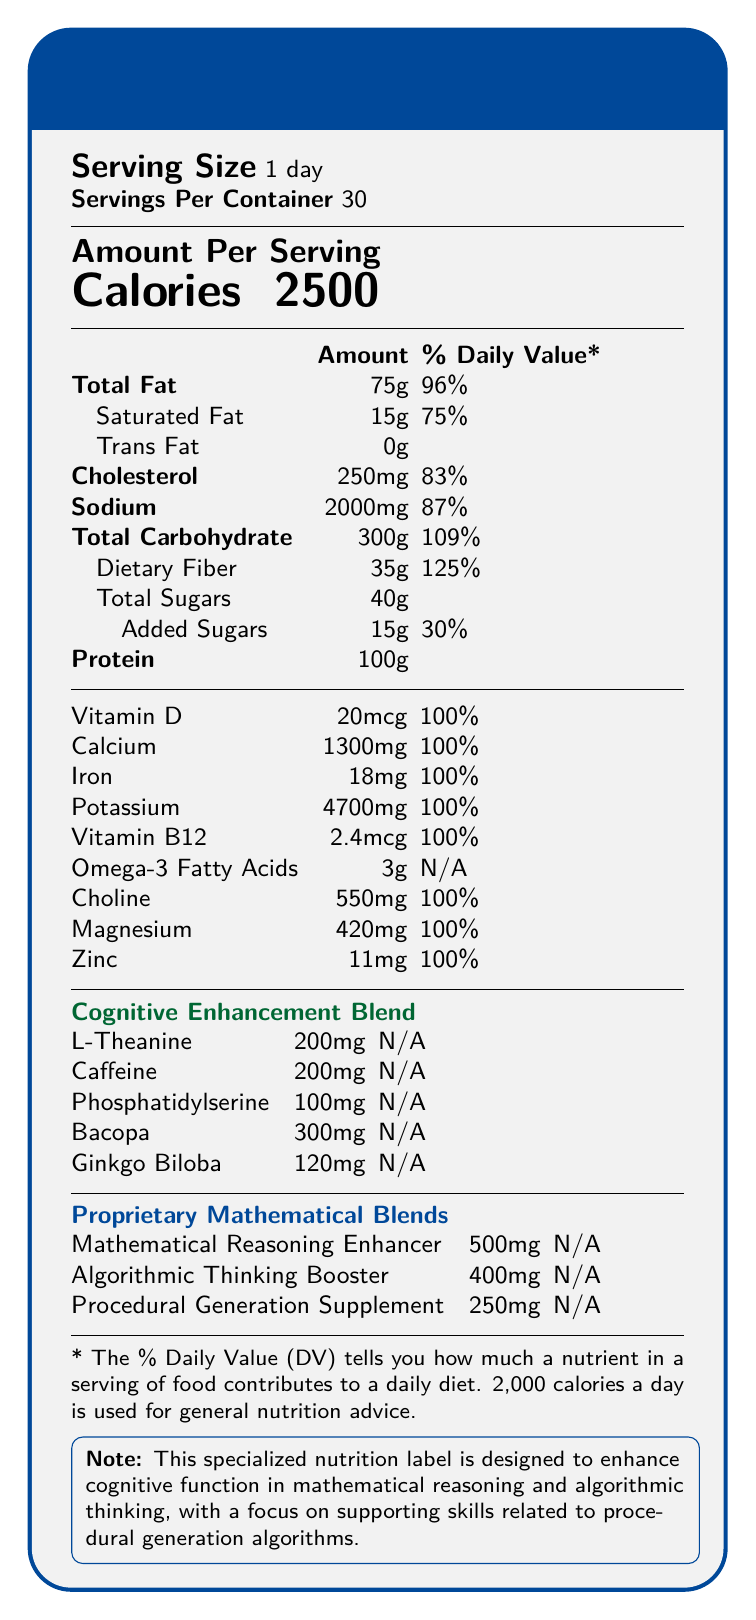what is the serving size? The serving size is explicitly listed at the top of the document as "Serving Size 1 day".
Answer: 1 day how many calories are there per serving? The document lists the calories as 2500 in the "Amount Per Serving" section.
Answer: 2500 what percentage of the daily value for total fat does one serving provide? The "Total Fat" section shows an amount of 75g, which corresponds to 96% of the daily value.
Answer: 96% how much vitamin D is in one serving, and what percentage of the daily value does it provide? The "Vitamin D" section lists the amount as 20mcg, with a daily value of 100%.
Answer: 20mcg, 100% how much caffeine is included in the cognitive enhancement blend? The "Cognitive Enhancement Blend" section lists caffeine as 200mg.
Answer: 200mg which proprietary blend is designed to enhance mathematical reasoning? The "Proprietary Mathematical Blends" section specifies that the "Mathematical Reasoning Enhancer" is designed to improve mathematical reasoning.
Answer: Mathematical Reasoning Enhancer what is the daily value percentage for dietary fiber per serving? A. 87% B. 100% C. 125% D. 30% The "Dietary Fiber" section lists 35g with a daily value of 125%.
Answer: C. 125% how much phosphatidylserine is in the cognitive enhancement blend? A. 120mg B. 250mg C. 100mg D. 300mg The "Cognitive Enhancement Blend" section lists phosphatidylserine as 100mg.
Answer: C. 100mg are omega-3 fatty acids included in the daily value percentage? The "Omega-3 Fatty Acids" section lists the amount as 3g but specifies "N/A" for the daily value.
Answer: No describe the main idea of the entire document. The document is structured as a nutrition label for a diet plan aimed at boosting cognitive skills related to mathematics and algorithms. It lists the amounts of major nutrients and cognitive supplements, along with their daily values, in a clear and organized format.
Answer: The nutrition facts label outlines the dietary content and daily values of various nutrients for a meal plan designed to enhance cognitive function, specifically focusing on mathematical reasoning, algorithmic thinking, and procedural generation. It details the amounts of macros, vitamins, minerals, and specialized cognitive enhancement blends included per serving, which is intended for daily consumption. which nutrient has the highest percentage of the daily value, and what is that percentage? In the "Total Carbohydrate" section, dietary fiber is listed with a daily value of 125%, which is the highest percentage stated.
Answer: Dietary Fiber, 125% what is the purpose of the procedural generation supplement? The description for the "Procedural Generation Supplement" states its purpose explicitly, which is to support cognitive processes involved in procedural generation algorithms.
Answer: To support cognitive processes involved in procedural generation algorithms how many servings are in one container? The "Servings Per Container" section at the top of the document lists 30 servings.
Answer: 30 what is the total amount of protein per serving? The "Protein" section lists the total amount as 100g.
Answer: 100g how much bacopa is included in the cognitive enhancement blend? The "Cognitive Enhancement Blend" section lists bacopa as 300mg.
Answer: 300mg is the percentage daily value of choline provided? The "Choline" section lists an amount of 550mg with a daily value of 100%.
Answer: Yes what's the main idea of the proprietary mathematical blends section? This section details the specific blends and their intended cognitive benefits, including the amounts of three different supplements.
Answer: The proprietary mathematical blends section outlines specialized compounds aimed at enhancing mathematical reasoning, algorithmic thinking, and cognitive processes for procedural generation algorithms, listing their amounts per serving. which nutrient doesn't have a daily value percentage listed? A. Vitamin D B. Choline C. Omega-3 Fatty Acids D. Magnesium The "Omega-3 Fatty Acids" section lists "N/A" for the daily value, unlike the other listed nutrients.
Answer: C. Omega-3 Fatty Acids how much zinc is in one serving, and what percentage of the daily value does it provide? The "Zinc" section lists the amount as 11mg, with a daily value of 100%.
Answer: 11mg, 100% what specific goals is the proprietary mathematical blends section designed to support? The descriptions for each blend (Mathematical Reasoning Enhancer, Algorithmic Thinking Booster, and Procedural Generation Supplement) outline their specific cognitive goals.
Answer: Enhancing mathematical reasoning, algorithmic thinking, and procedural generation cognitive processes is the total amount of added sugars provided? The "Added Sugars" section lists the amount as 15g with a daily value of 30%.
Answer: Yes how many nutrients in the label have their amount listed in mcg? Both "Vitamin D" (20mcg) and "Vitamin B12" (2.4mcg) have their amounts listed in micrograms (mcg).
Answer: Two how much mathematical reasoning enhancer is included per serving? The "Proprietary Mathematical Blends" section lists the Mathematical Reasoning Enhancer as 500mg.
Answer: 500mg does the document mention the source of the bacopa used in the blend? The document does not specify the source of bacopa, only that it is included in the cognitive enhancement blend at 300mg.
Answer: Not enough information 